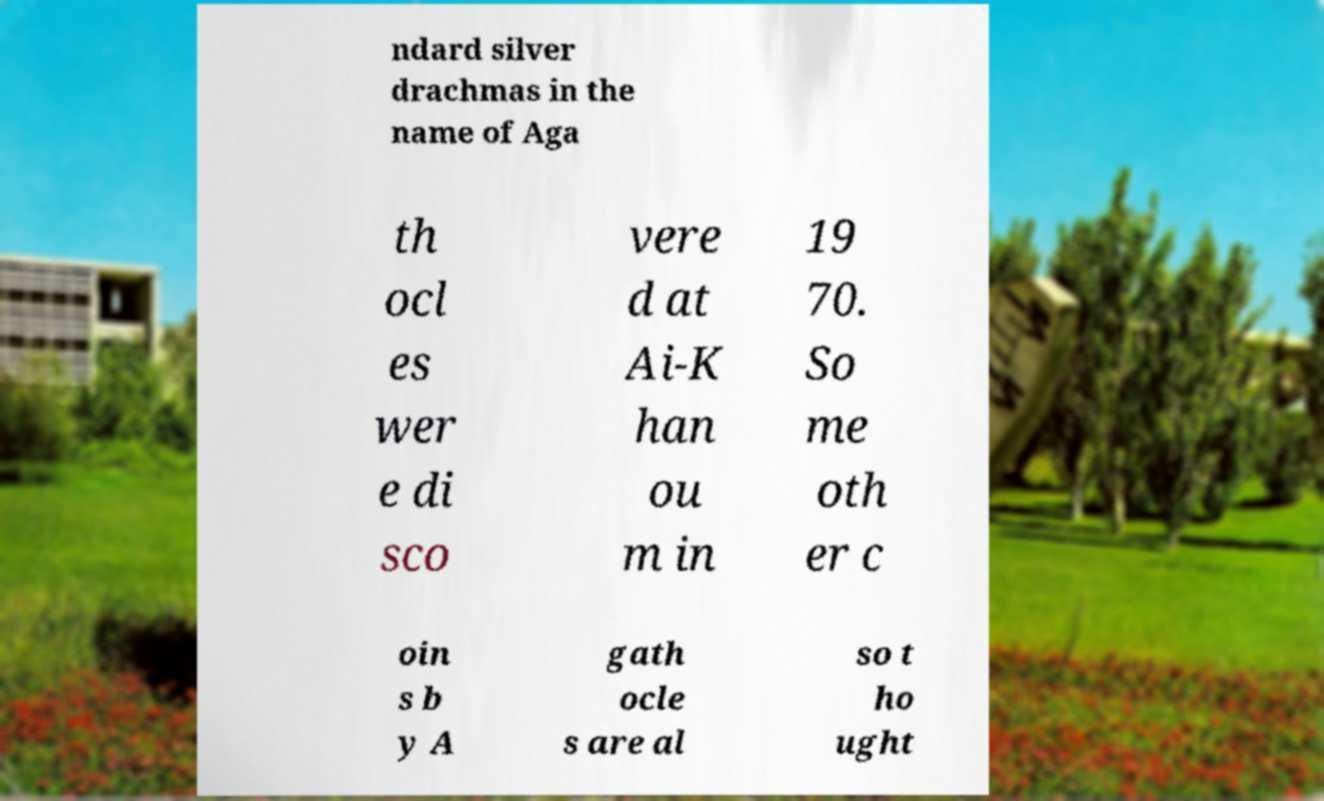For documentation purposes, I need the text within this image transcribed. Could you provide that? ndard silver drachmas in the name of Aga th ocl es wer e di sco vere d at Ai-K han ou m in 19 70. So me oth er c oin s b y A gath ocle s are al so t ho ught 